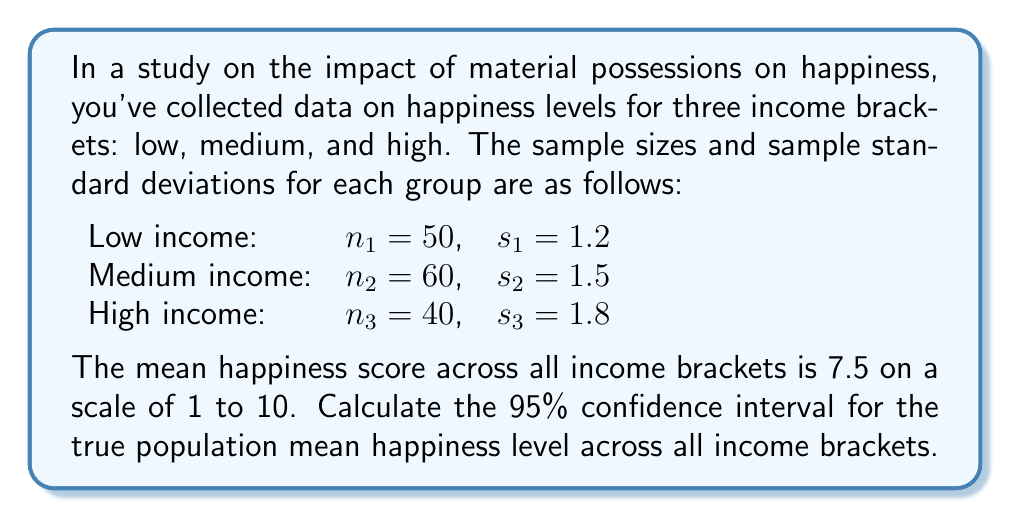Show me your answer to this math problem. To calculate the confidence interval for the mean happiness level across all income brackets, we'll use the formula:

$$ CI = \bar{x} \pm t_{\alpha/2} \cdot SE_{\bar{x}} $$

Where:
$\bar{x}$ is the sample mean (given as 7.5)
$t_{\alpha/2}$ is the t-value for a 95% confidence level
$SE_{\bar{x}}$ is the standard error of the mean

Steps:

1) Calculate the total sample size:
   $n = n_1 + n_2 + n_3 = 50 + 60 + 40 = 150$

2) Calculate the pooled standard deviation:
   $s_p = \sqrt{\frac{(n_1-1)s_1^2 + (n_2-1)s_2^2 + (n_3-1)s_3^2}{n-3}}$
   $s_p = \sqrt{\frac{(49)(1.2^2) + (59)(1.5^2) + (39)(1.8^2)}{147}} = 1.5$

3) Calculate the standard error:
   $SE_{\bar{x}} = \frac{s_p}{\sqrt{n}} = \frac{1.5}{\sqrt{150}} = 0.1225$

4) Find the t-value for 95% confidence level with 147 degrees of freedom:
   $t_{0.025,147} \approx 1.976$ (using t-table or calculator)

5) Calculate the margin of error:
   $ME = t_{0.025,147} \cdot SE_{\bar{x}} = 1.976 \cdot 0.1225 = 0.2421$

6) Compute the confidence interval:
   $CI = 7.5 \pm 0.2421$
   $CI = (7.2579, 7.7421)$
Answer: The 95% confidence interval for the true population mean happiness level across all income brackets is (7.2579, 7.7421). 